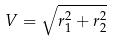Convert formula to latex. <formula><loc_0><loc_0><loc_500><loc_500>V = \sqrt { r _ { 1 } ^ { 2 } + r _ { 2 } ^ { 2 } }</formula> 